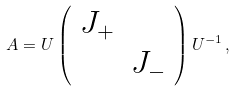Convert formula to latex. <formula><loc_0><loc_0><loc_500><loc_500>A = U \left ( \begin{array} { c c } J _ { + } & \\ & J _ { - } \end{array} \right ) U ^ { - 1 } \, ,</formula> 